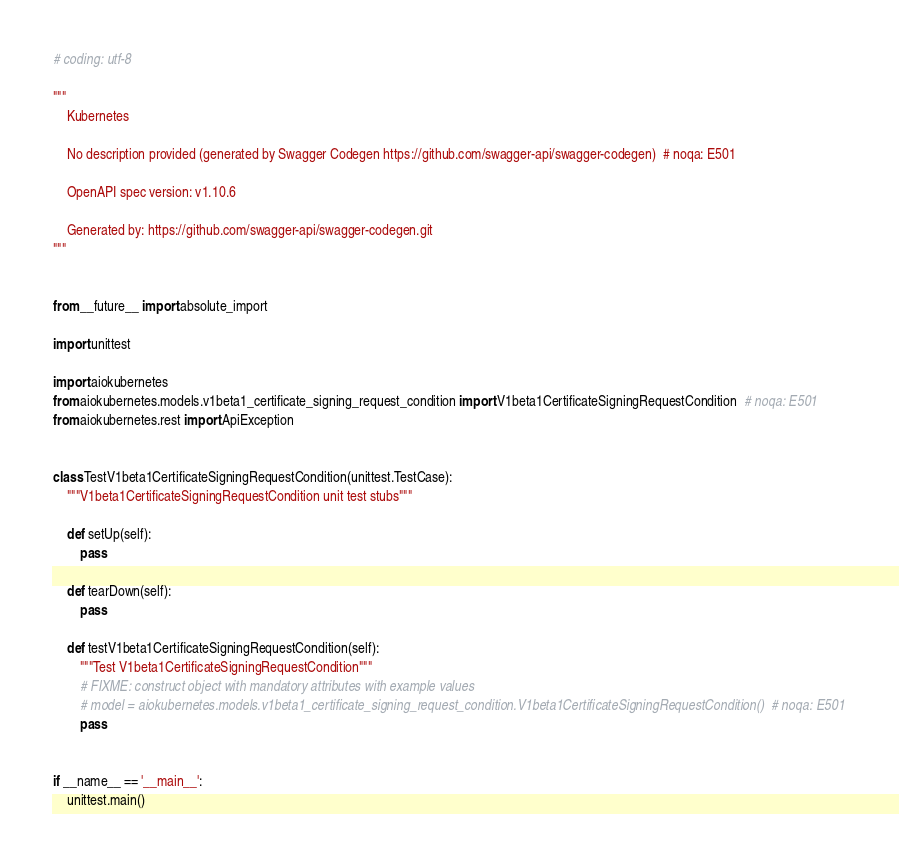Convert code to text. <code><loc_0><loc_0><loc_500><loc_500><_Python_># coding: utf-8

"""
    Kubernetes

    No description provided (generated by Swagger Codegen https://github.com/swagger-api/swagger-codegen)  # noqa: E501

    OpenAPI spec version: v1.10.6
    
    Generated by: https://github.com/swagger-api/swagger-codegen.git
"""


from __future__ import absolute_import

import unittest

import aiokubernetes
from aiokubernetes.models.v1beta1_certificate_signing_request_condition import V1beta1CertificateSigningRequestCondition  # noqa: E501
from aiokubernetes.rest import ApiException


class TestV1beta1CertificateSigningRequestCondition(unittest.TestCase):
    """V1beta1CertificateSigningRequestCondition unit test stubs"""

    def setUp(self):
        pass

    def tearDown(self):
        pass

    def testV1beta1CertificateSigningRequestCondition(self):
        """Test V1beta1CertificateSigningRequestCondition"""
        # FIXME: construct object with mandatory attributes with example values
        # model = aiokubernetes.models.v1beta1_certificate_signing_request_condition.V1beta1CertificateSigningRequestCondition()  # noqa: E501
        pass


if __name__ == '__main__':
    unittest.main()
</code> 